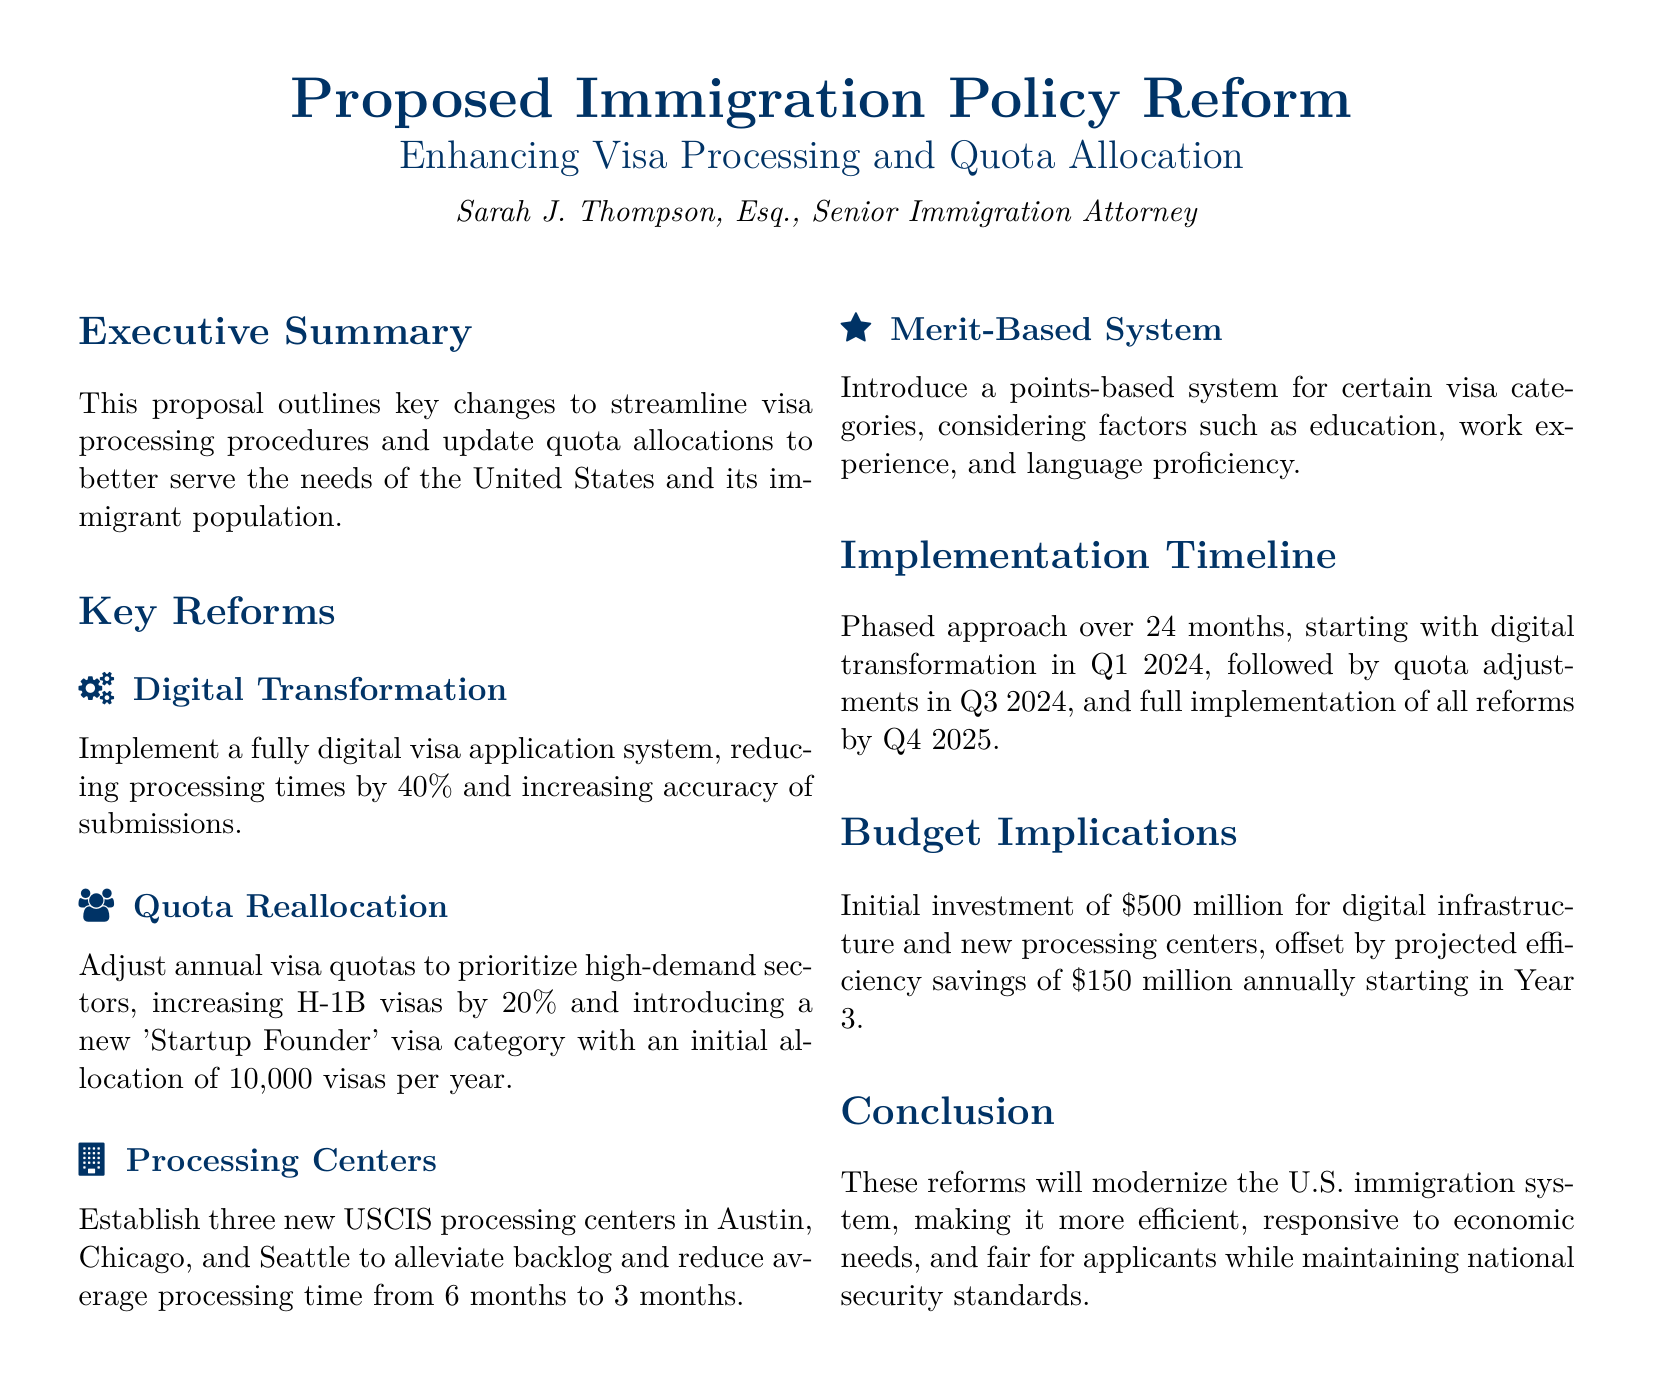What is the proposed investment for digital infrastructure? The document states that the initial investment for digital infrastructure and new processing centers is $500 million.
Answer: $500 million In which quarter is the digital transformation expected to start? The implementation timeline specifies that the digital transformation will begin in Q1 2024.
Answer: Q1 2024 How much will H-1B visas increase by? The quota reallocation section indicates that H-1B visas will be increased by 20%.
Answer: 20% What is the initial allocation for the new 'Startup Founder' visa category? The document mentions the initial allocation of 10,000 visas per year for the new 'Startup Founder' visa category.
Answer: 10,000 visas What is the reduction in average processing time expected? According to the key reforms, the average processing time is expected to be reduced from 6 months to 3 months.
Answer: 3 months What is the projected annual efficiency savings starting in Year 3? The budget implications section indicates that the projected efficiency savings will be $150 million annually starting in Year 3.
Answer: $150 million What type of system is being introduced for certain visa categories? The document states that a points-based system is being introduced for certain visa categories.
Answer: Points-based system How many new USCIS processing centers are to be established? The key reforms section outlines that three new USCIS processing centers will be established.
Answer: Three What is the total duration for the proposed implementation timeline? The timeline specifies a phased approach over 24 months for full implementation of all reforms.
Answer: 24 months 